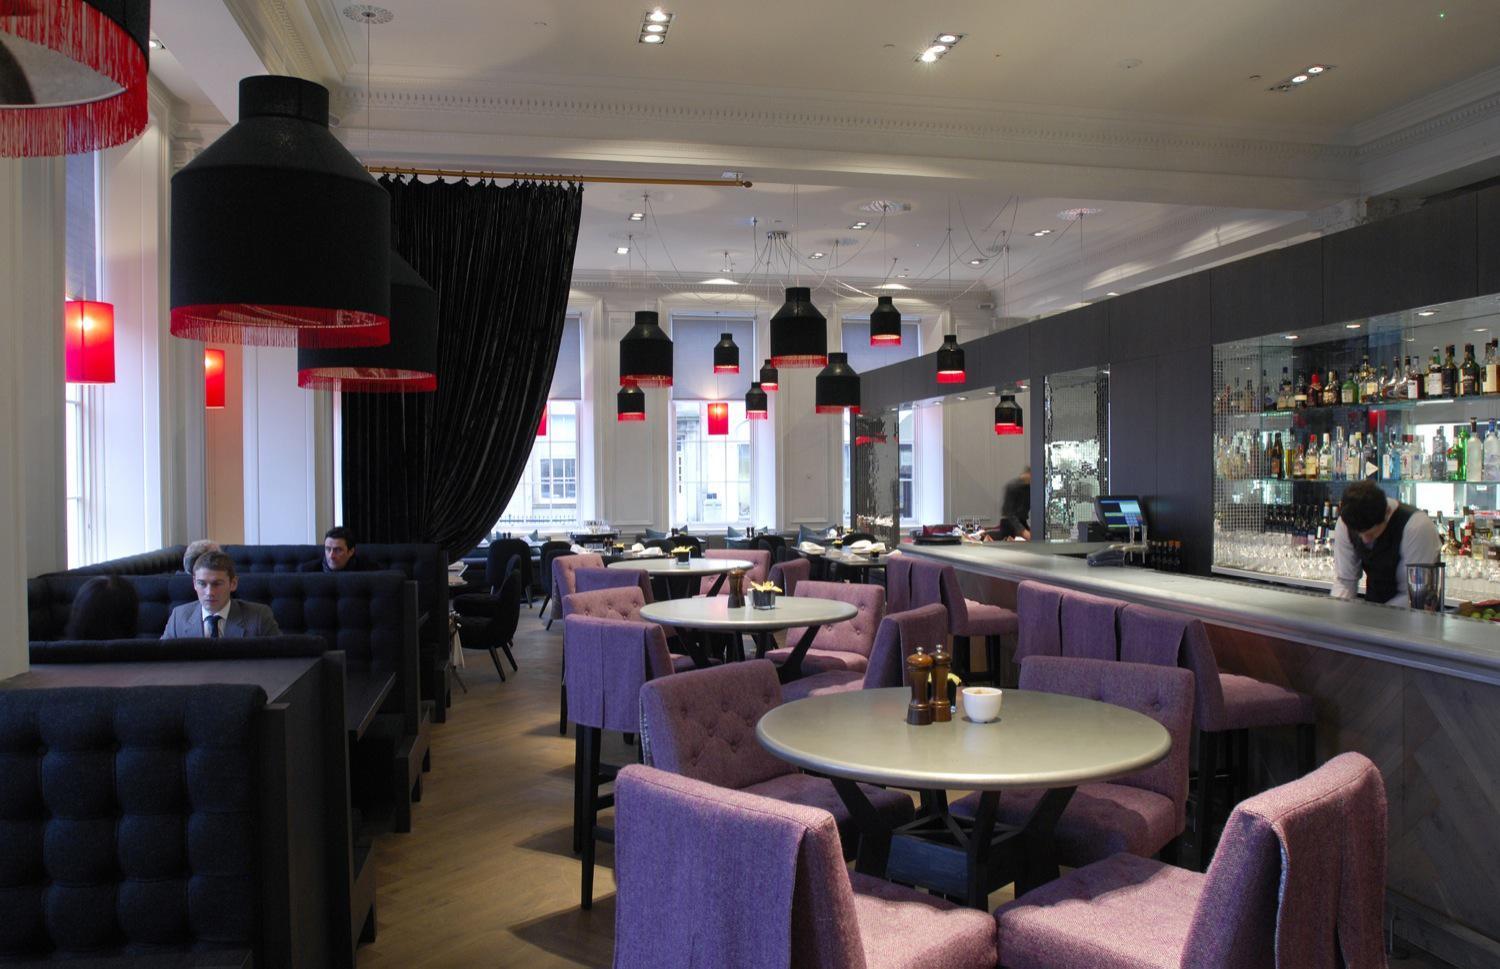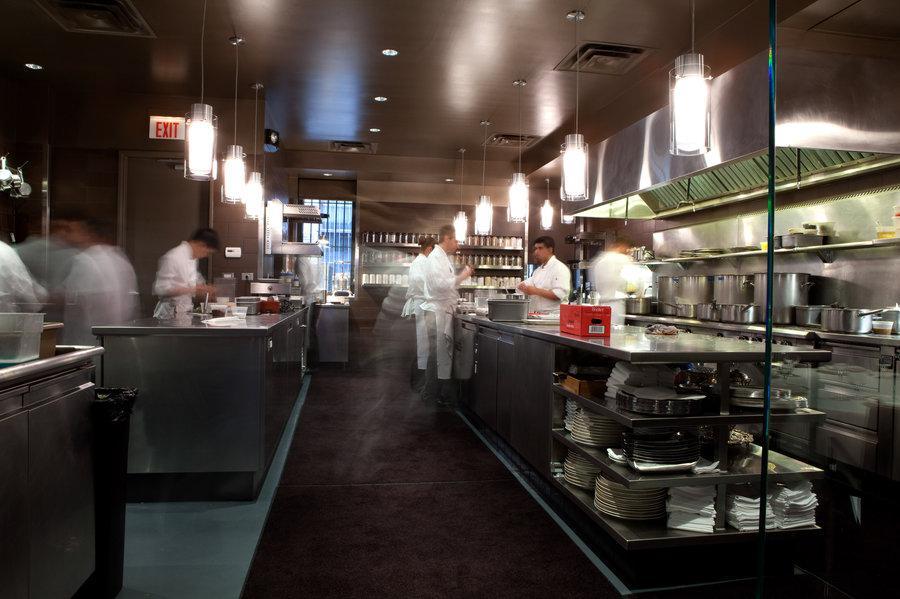The first image is the image on the left, the second image is the image on the right. For the images shown, is this caption "One restaurant interior features multiple cyclindrical black and red suspended lights over the seating area." true? Answer yes or no. Yes. 